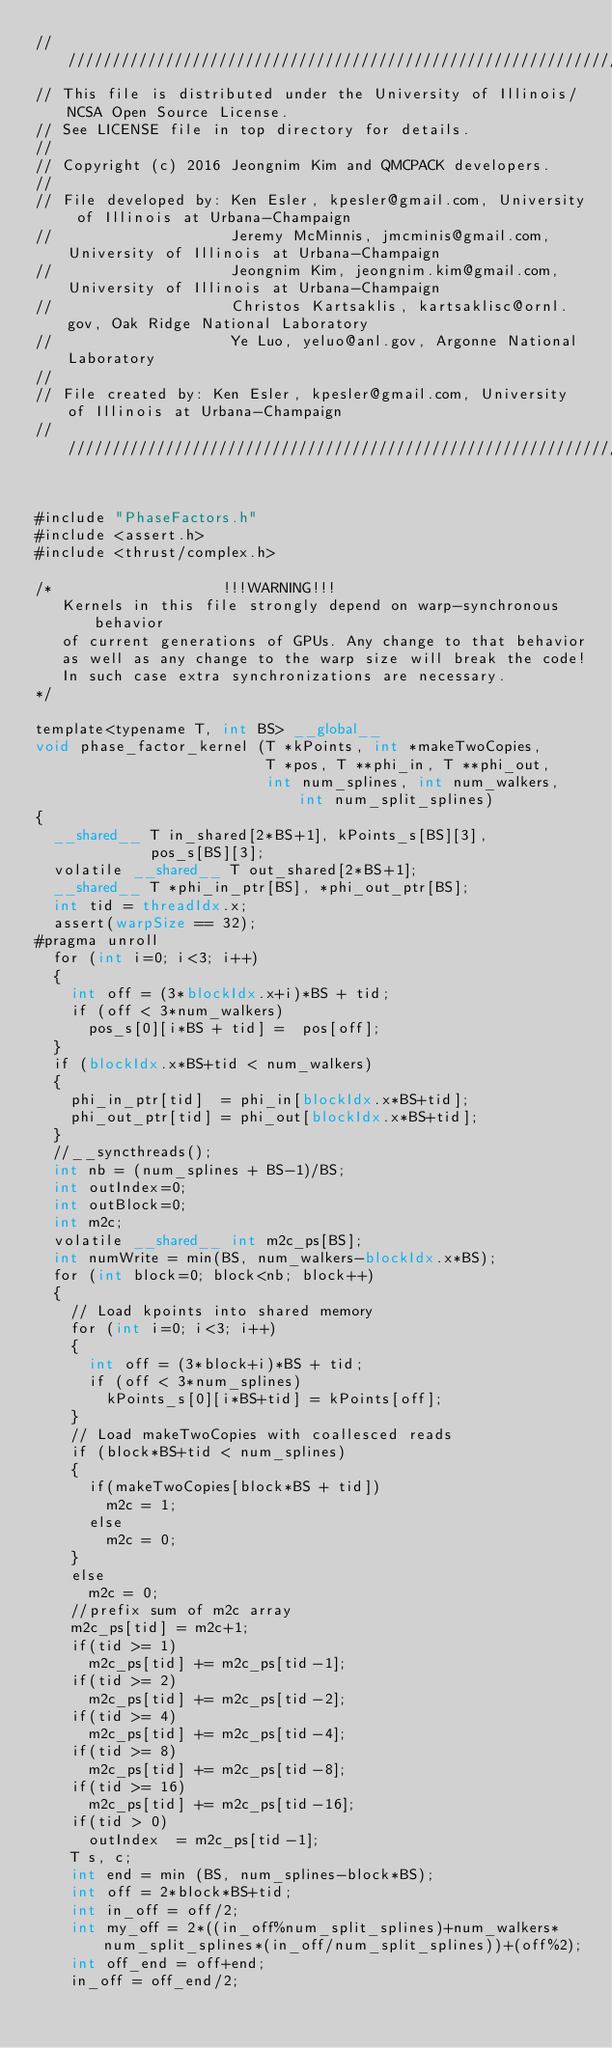<code> <loc_0><loc_0><loc_500><loc_500><_Cuda_>//////////////////////////////////////////////////////////////////////////////////////
// This file is distributed under the University of Illinois/NCSA Open Source License.
// See LICENSE file in top directory for details.
//
// Copyright (c) 2016 Jeongnim Kim and QMCPACK developers.
//
// File developed by: Ken Esler, kpesler@gmail.com, University of Illinois at Urbana-Champaign
//                    Jeremy McMinnis, jmcminis@gmail.com, University of Illinois at Urbana-Champaign
//                    Jeongnim Kim, jeongnim.kim@gmail.com, University of Illinois at Urbana-Champaign
//                    Christos Kartsaklis, kartsaklisc@ornl.gov, Oak Ridge National Laboratory
//                    Ye Luo, yeluo@anl.gov, Argonne National Laboratory
//
// File created by: Ken Esler, kpesler@gmail.com, University of Illinois at Urbana-Champaign
//////////////////////////////////////////////////////////////////////////////////////
    
    
#include "PhaseFactors.h"
#include <assert.h>
#include <thrust/complex.h>

/*                   !!!WARNING!!!
   Kernels in this file strongly depend on warp-synchronous behavior
   of current generations of GPUs. Any change to that behavior
   as well as any change to the warp size will break the code!
   In such case extra synchronizations are necessary.
*/

template<typename T, int BS> __global__
void phase_factor_kernel (T *kPoints, int *makeTwoCopies,
                          T *pos, T **phi_in, T **phi_out,
                          int num_splines, int num_walkers, int num_split_splines)
{
  __shared__ T in_shared[2*BS+1], kPoints_s[BS][3],
             pos_s[BS][3];
  volatile __shared__ T out_shared[2*BS+1];
  __shared__ T *phi_in_ptr[BS], *phi_out_ptr[BS];
  int tid = threadIdx.x;
  assert(warpSize == 32);
#pragma unroll
  for (int i=0; i<3; i++)
  {
    int off = (3*blockIdx.x+i)*BS + tid;
    if (off < 3*num_walkers)
      pos_s[0][i*BS + tid] =  pos[off];
  }
  if (blockIdx.x*BS+tid < num_walkers)
  {
    phi_in_ptr[tid]  = phi_in[blockIdx.x*BS+tid];
    phi_out_ptr[tid] = phi_out[blockIdx.x*BS+tid];
  }
  //__syncthreads();
  int nb = (num_splines + BS-1)/BS;
  int outIndex=0;
  int outBlock=0;
  int m2c;
  volatile __shared__ int m2c_ps[BS];
  int numWrite = min(BS, num_walkers-blockIdx.x*BS);
  for (int block=0; block<nb; block++)
  {
    // Load kpoints into shared memory
    for (int i=0; i<3; i++)
    {
      int off = (3*block+i)*BS + tid;
      if (off < 3*num_splines)
        kPoints_s[0][i*BS+tid] = kPoints[off];
    }
    // Load makeTwoCopies with coallesced reads
    if (block*BS+tid < num_splines)
    {
      if(makeTwoCopies[block*BS + tid])
        m2c = 1;
      else
        m2c = 0;
    }
    else
      m2c = 0;
    //prefix sum of m2c array
    m2c_ps[tid] = m2c+1;
    if(tid >= 1)
      m2c_ps[tid] += m2c_ps[tid-1];
    if(tid >= 2)
      m2c_ps[tid] += m2c_ps[tid-2];
    if(tid >= 4)
      m2c_ps[tid] += m2c_ps[tid-4];
    if(tid >= 8)
      m2c_ps[tid] += m2c_ps[tid-8];
    if(tid >= 16)
      m2c_ps[tid] += m2c_ps[tid-16];
    if(tid > 0)
      outIndex  = m2c_ps[tid-1];
    T s, c;
    int end = min (BS, num_splines-block*BS);
    int off = 2*block*BS+tid;
    int in_off = off/2;
    int my_off = 2*((in_off%num_split_splines)+num_walkers*num_split_splines*(in_off/num_split_splines))+(off%2);
    int off_end = off+end;
    in_off = off_end/2;</code> 